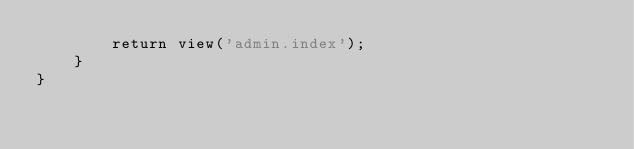<code> <loc_0><loc_0><loc_500><loc_500><_PHP_>        return view('admin.index');
    }
}
</code> 